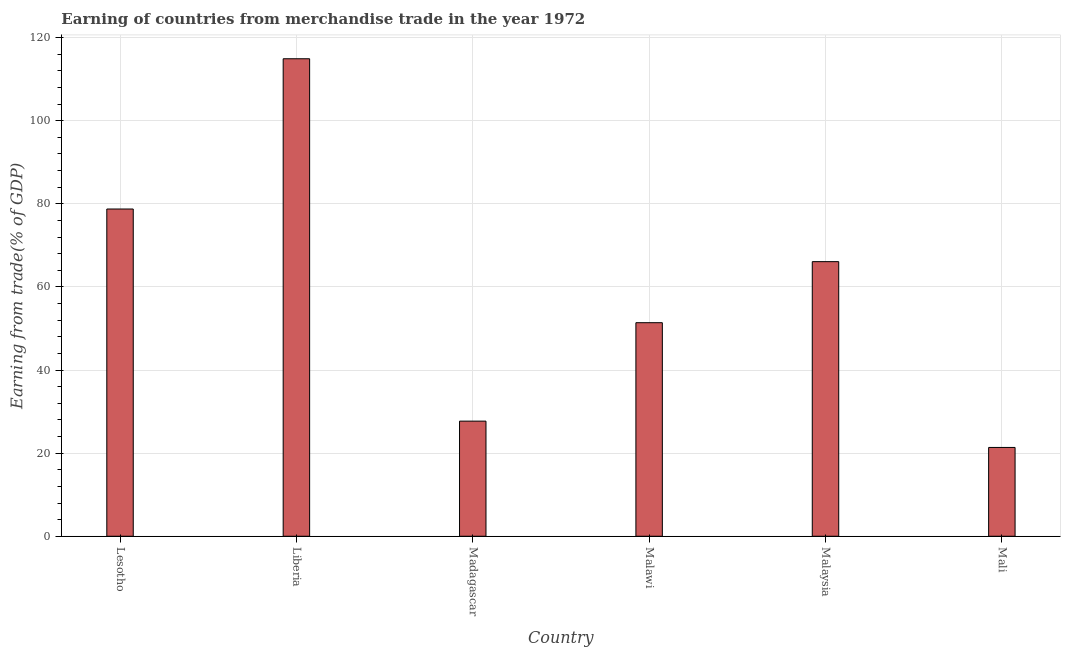Does the graph contain any zero values?
Provide a short and direct response. No. What is the title of the graph?
Make the answer very short. Earning of countries from merchandise trade in the year 1972. What is the label or title of the X-axis?
Ensure brevity in your answer.  Country. What is the label or title of the Y-axis?
Provide a short and direct response. Earning from trade(% of GDP). What is the earning from merchandise trade in Liberia?
Ensure brevity in your answer.  114.92. Across all countries, what is the maximum earning from merchandise trade?
Provide a succinct answer. 114.92. Across all countries, what is the minimum earning from merchandise trade?
Provide a succinct answer. 21.37. In which country was the earning from merchandise trade maximum?
Provide a succinct answer. Liberia. In which country was the earning from merchandise trade minimum?
Offer a very short reply. Mali. What is the sum of the earning from merchandise trade?
Give a very brief answer. 360.22. What is the difference between the earning from merchandise trade in Lesotho and Liberia?
Your answer should be very brief. -36.16. What is the average earning from merchandise trade per country?
Your answer should be compact. 60.04. What is the median earning from merchandise trade?
Your answer should be compact. 58.74. In how many countries, is the earning from merchandise trade greater than 92 %?
Give a very brief answer. 1. What is the ratio of the earning from merchandise trade in Liberia to that in Madagascar?
Your response must be concise. 4.15. Is the difference between the earning from merchandise trade in Lesotho and Liberia greater than the difference between any two countries?
Offer a very short reply. No. What is the difference between the highest and the second highest earning from merchandise trade?
Your response must be concise. 36.16. Is the sum of the earning from merchandise trade in Madagascar and Mali greater than the maximum earning from merchandise trade across all countries?
Your response must be concise. No. What is the difference between the highest and the lowest earning from merchandise trade?
Keep it short and to the point. 93.54. In how many countries, is the earning from merchandise trade greater than the average earning from merchandise trade taken over all countries?
Your answer should be very brief. 3. How many bars are there?
Keep it short and to the point. 6. Are all the bars in the graph horizontal?
Ensure brevity in your answer.  No. How many countries are there in the graph?
Your answer should be compact. 6. What is the Earning from trade(% of GDP) of Lesotho?
Give a very brief answer. 78.75. What is the Earning from trade(% of GDP) in Liberia?
Provide a short and direct response. 114.92. What is the Earning from trade(% of GDP) of Madagascar?
Keep it short and to the point. 27.7. What is the Earning from trade(% of GDP) of Malawi?
Ensure brevity in your answer.  51.39. What is the Earning from trade(% of GDP) of Malaysia?
Your response must be concise. 66.08. What is the Earning from trade(% of GDP) of Mali?
Provide a succinct answer. 21.37. What is the difference between the Earning from trade(% of GDP) in Lesotho and Liberia?
Your answer should be very brief. -36.16. What is the difference between the Earning from trade(% of GDP) in Lesotho and Madagascar?
Your answer should be compact. 51.05. What is the difference between the Earning from trade(% of GDP) in Lesotho and Malawi?
Ensure brevity in your answer.  27.36. What is the difference between the Earning from trade(% of GDP) in Lesotho and Malaysia?
Your answer should be compact. 12.67. What is the difference between the Earning from trade(% of GDP) in Lesotho and Mali?
Your response must be concise. 57.38. What is the difference between the Earning from trade(% of GDP) in Liberia and Madagascar?
Make the answer very short. 87.21. What is the difference between the Earning from trade(% of GDP) in Liberia and Malawi?
Provide a succinct answer. 63.52. What is the difference between the Earning from trade(% of GDP) in Liberia and Malaysia?
Provide a succinct answer. 48.83. What is the difference between the Earning from trade(% of GDP) in Liberia and Mali?
Offer a terse response. 93.54. What is the difference between the Earning from trade(% of GDP) in Madagascar and Malawi?
Your response must be concise. -23.69. What is the difference between the Earning from trade(% of GDP) in Madagascar and Malaysia?
Give a very brief answer. -38.38. What is the difference between the Earning from trade(% of GDP) in Madagascar and Mali?
Offer a very short reply. 6.33. What is the difference between the Earning from trade(% of GDP) in Malawi and Malaysia?
Make the answer very short. -14.69. What is the difference between the Earning from trade(% of GDP) in Malawi and Mali?
Ensure brevity in your answer.  30.02. What is the difference between the Earning from trade(% of GDP) in Malaysia and Mali?
Ensure brevity in your answer.  44.71. What is the ratio of the Earning from trade(% of GDP) in Lesotho to that in Liberia?
Offer a very short reply. 0.69. What is the ratio of the Earning from trade(% of GDP) in Lesotho to that in Madagascar?
Ensure brevity in your answer.  2.84. What is the ratio of the Earning from trade(% of GDP) in Lesotho to that in Malawi?
Offer a very short reply. 1.53. What is the ratio of the Earning from trade(% of GDP) in Lesotho to that in Malaysia?
Offer a very short reply. 1.19. What is the ratio of the Earning from trade(% of GDP) in Lesotho to that in Mali?
Your response must be concise. 3.69. What is the ratio of the Earning from trade(% of GDP) in Liberia to that in Madagascar?
Your response must be concise. 4.15. What is the ratio of the Earning from trade(% of GDP) in Liberia to that in Malawi?
Keep it short and to the point. 2.24. What is the ratio of the Earning from trade(% of GDP) in Liberia to that in Malaysia?
Your response must be concise. 1.74. What is the ratio of the Earning from trade(% of GDP) in Liberia to that in Mali?
Give a very brief answer. 5.38. What is the ratio of the Earning from trade(% of GDP) in Madagascar to that in Malawi?
Offer a very short reply. 0.54. What is the ratio of the Earning from trade(% of GDP) in Madagascar to that in Malaysia?
Offer a very short reply. 0.42. What is the ratio of the Earning from trade(% of GDP) in Madagascar to that in Mali?
Your response must be concise. 1.3. What is the ratio of the Earning from trade(% of GDP) in Malawi to that in Malaysia?
Offer a terse response. 0.78. What is the ratio of the Earning from trade(% of GDP) in Malawi to that in Mali?
Provide a succinct answer. 2.4. What is the ratio of the Earning from trade(% of GDP) in Malaysia to that in Mali?
Provide a short and direct response. 3.09. 